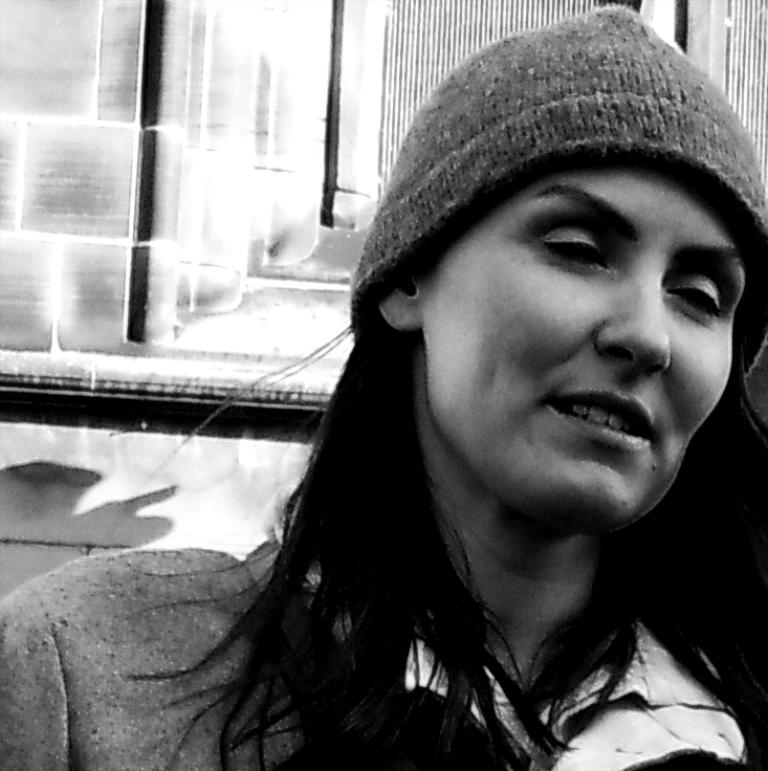What is the color scheme of the image? The image is black and white. Who is present in the image? There is a woman in the image. What is the woman wearing on her head? The woman is wearing a cap on her head. What can be seen in the background of the image? There is a wall and window doors in the background of the image. How many cats are playing in the recess in the image? There are no cats or recess present in the image. What type of substance is being used by the woman in the image? There is no substance being used by the woman in the image; she is simply wearing a cap. 